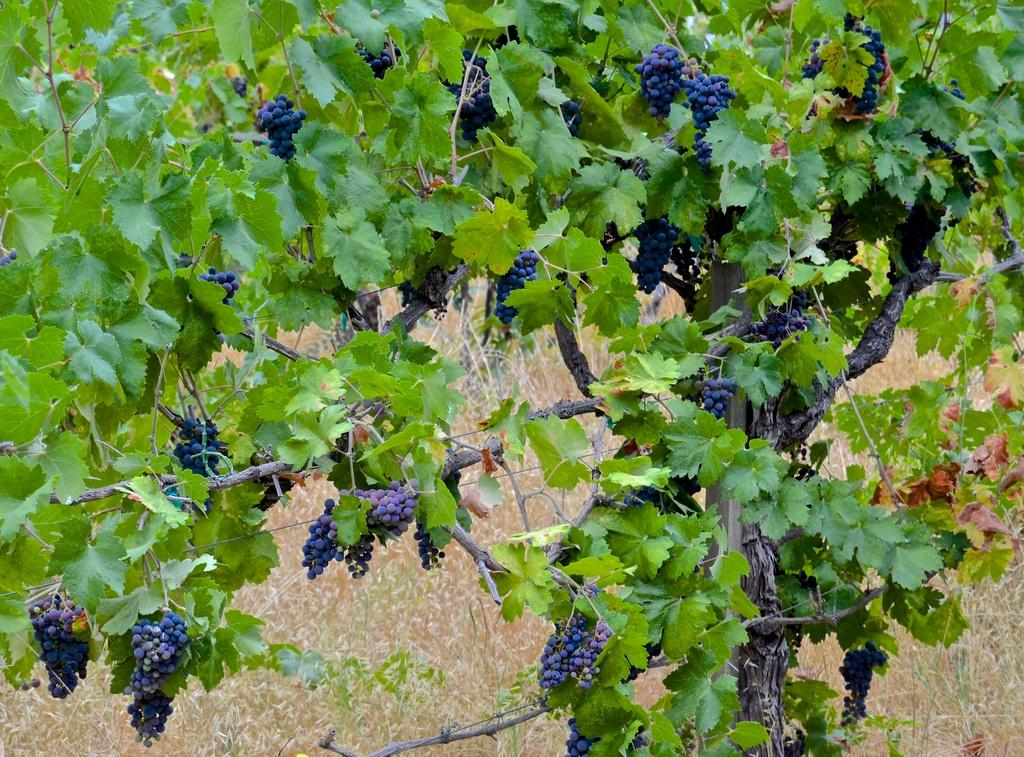What type of fruit is present in the image? There are grapes in the image. What else can be seen in the image besides the grapes? There are leaves visible in the image. What type of vegetation can be seen in the background of the image? There is grass visible in the background of the image. What type of crack is visible in the image? There is no crack present in the image. Can you see any buildings in the image? There is no building present in the image. 